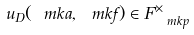<formula> <loc_0><loc_0><loc_500><loc_500>u _ { D } ( \ m k { a } , \ m k { f } ) \in F _ { \ m k { p } } ^ { \times }</formula> 